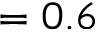Convert formula to latex. <formula><loc_0><loc_0><loc_500><loc_500>= 0 . 6</formula> 